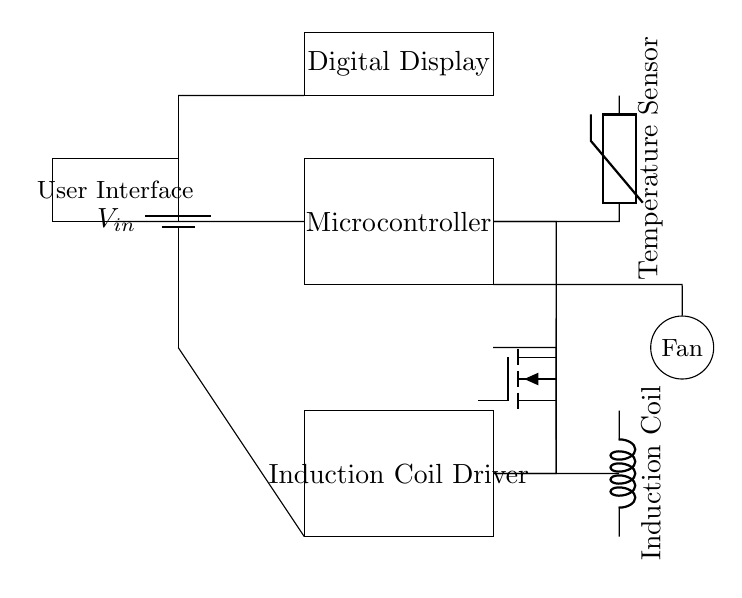What is the role of the microcontroller in this circuit? The microcontroller processes data from the temperature sensor and controls the induction coil driver based on the temperature readings. It is essential for automated cooking processes where precise temperature control is required.
Answer: Processing and control What type of temperature sensor is used in the circuit? The circuit uses a thermistor as the temperature sensor, which changes resistance with temperature variations and provides input to the microcontroller for temperature monitoring.
Answer: Thermistor How many main components are in the circuit? The main components include the microcontroller, temperature sensor, digital display, induction coil driver, induction coil, user interface, and fan, totaling seven significant parts.
Answer: Seven What is the purpose of the induction coil driver? The induction coil driver amplifies the signal from the microcontroller to effectively power the induction coil, generating the magnetic field necessary for induction heating.
Answer: Power amplification Which component connects directly to the digital display? The digital display is directly connected to the microcontroller, allowing it to show the temperature readings processed by the microcontroller in real-time.
Answer: Microcontroller Why is a cooling fan included in the circuit? The cooling fan helps dissipate heat generated by the induction coil during operation, ensuring the device maintains a safe operating temperature and prevents overheating.
Answer: Overheating prevention 